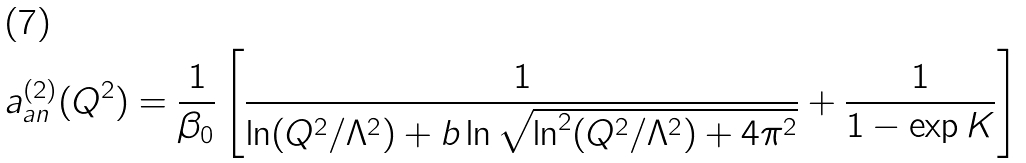<formula> <loc_0><loc_0><loc_500><loc_500>a _ { a n } ^ { ( 2 ) } ( Q ^ { 2 } ) = \frac { 1 } { \beta _ { 0 } } \left [ \frac { 1 } { \ln ( Q ^ { 2 } / \Lambda ^ { 2 } ) + b \ln \sqrt { \ln ^ { 2 } ( Q ^ { 2 } / \Lambda ^ { 2 } ) + 4 \pi ^ { 2 } } } + \frac { 1 } { 1 - \exp { K } } \right ]</formula> 